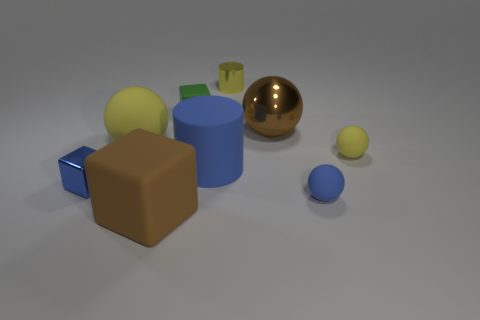Subtract all big blocks. How many blocks are left? 2 Subtract all green blocks. How many blocks are left? 2 Add 1 rubber spheres. How many objects exist? 10 Subtract all cubes. How many objects are left? 6 Subtract 2 spheres. How many spheres are left? 2 Subtract all red blocks. Subtract all blue balls. How many blocks are left? 3 Subtract all brown spheres. How many yellow cylinders are left? 1 Subtract all small blue spheres. Subtract all small green rubber things. How many objects are left? 7 Add 7 green matte objects. How many green matte objects are left? 8 Add 2 big yellow matte things. How many big yellow matte things exist? 3 